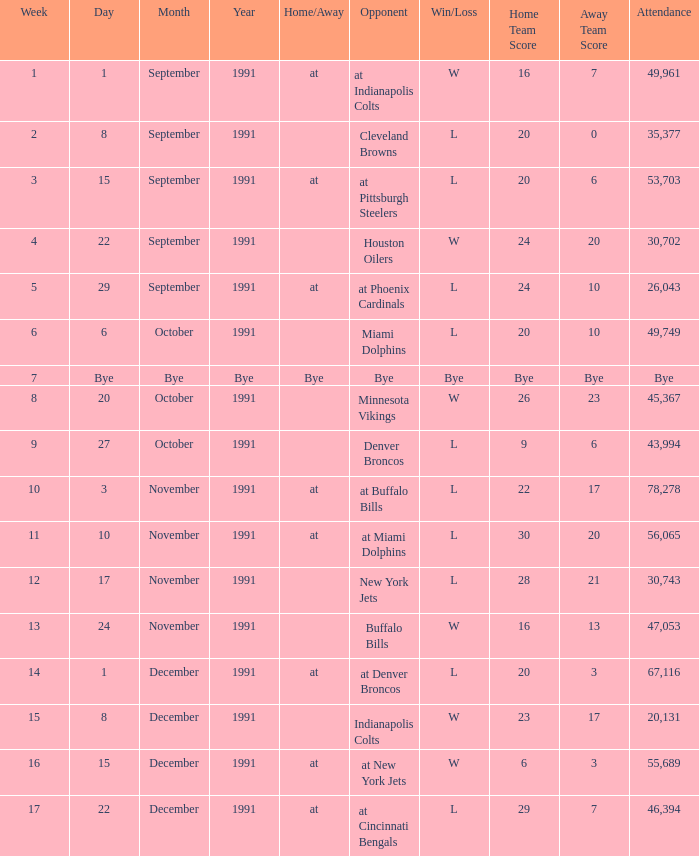What was the result of the game on December 22, 1991? L 29–7. Could you help me parse every detail presented in this table? {'header': ['Week', 'Day', 'Month', 'Year', 'Home/Away', 'Opponent', 'Win/Loss', 'Home Team Score', 'Away Team Score', 'Attendance'], 'rows': [['1', '1', 'September', '1991', 'at', 'at Indianapolis Colts', 'W', '16', '7', '49,961'], ['2', '8', 'September', '1991', '', 'Cleveland Browns', 'L', '20', '0', '35,377'], ['3', '15', 'September', '1991', 'at', 'at Pittsburgh Steelers', 'L', '20', '6', '53,703'], ['4', '22', 'September', '1991', '', 'Houston Oilers', 'W', '24', '20', '30,702'], ['5', '29', 'September', '1991', 'at', 'at Phoenix Cardinals', 'L', '24', '10', '26,043'], ['6', '6', 'October', '1991', '', 'Miami Dolphins', 'L', '20', '10', '49,749'], ['7', 'Bye', 'Bye', 'Bye', 'Bye', 'Bye', 'Bye', 'Bye', 'Bye', 'Bye'], ['8', '20', 'October', '1991', '', 'Minnesota Vikings', 'W', '26', '23', '45,367'], ['9', '27', 'October', '1991', '', 'Denver Broncos', 'L', '9', '6', '43,994'], ['10', '3', 'November', '1991', 'at', 'at Buffalo Bills', 'L', '22', '17', '78,278'], ['11', '10', 'November', '1991', 'at', 'at Miami Dolphins', 'L', '30', '20', '56,065'], ['12', '17', 'November', '1991', '', 'New York Jets', 'L', '28', '21', '30,743'], ['13', '24', 'November', '1991', '', 'Buffalo Bills', 'W', '16', '13', '47,053'], ['14', '1', 'December', '1991', 'at', 'at Denver Broncos', 'L', '20', '3', '67,116'], ['15', '8', 'December', '1991', '', 'Indianapolis Colts', 'W', '23', '17', '20,131'], ['16', '15', 'December', '1991', 'at', 'at New York Jets', 'W', '6', '3', '55,689'], ['17', '22', 'December', '1991', 'at', 'at Cincinnati Bengals', 'L', '29', '7', '46,394']]} 